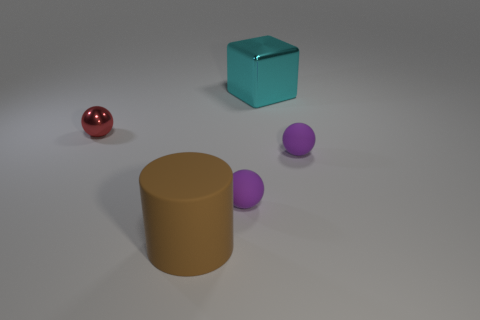Subtract all matte balls. How many balls are left? 1 Subtract all cyan cubes. How many purple spheres are left? 2 Subtract all purple spheres. How many spheres are left? 1 Add 1 large brown cylinders. How many objects exist? 6 Subtract all small red things. Subtract all large matte cylinders. How many objects are left? 3 Add 5 shiny cubes. How many shiny cubes are left? 6 Add 3 cyan objects. How many cyan objects exist? 4 Subtract 1 cyan cubes. How many objects are left? 4 Subtract all balls. How many objects are left? 2 Subtract all brown blocks. Subtract all gray cylinders. How many blocks are left? 1 